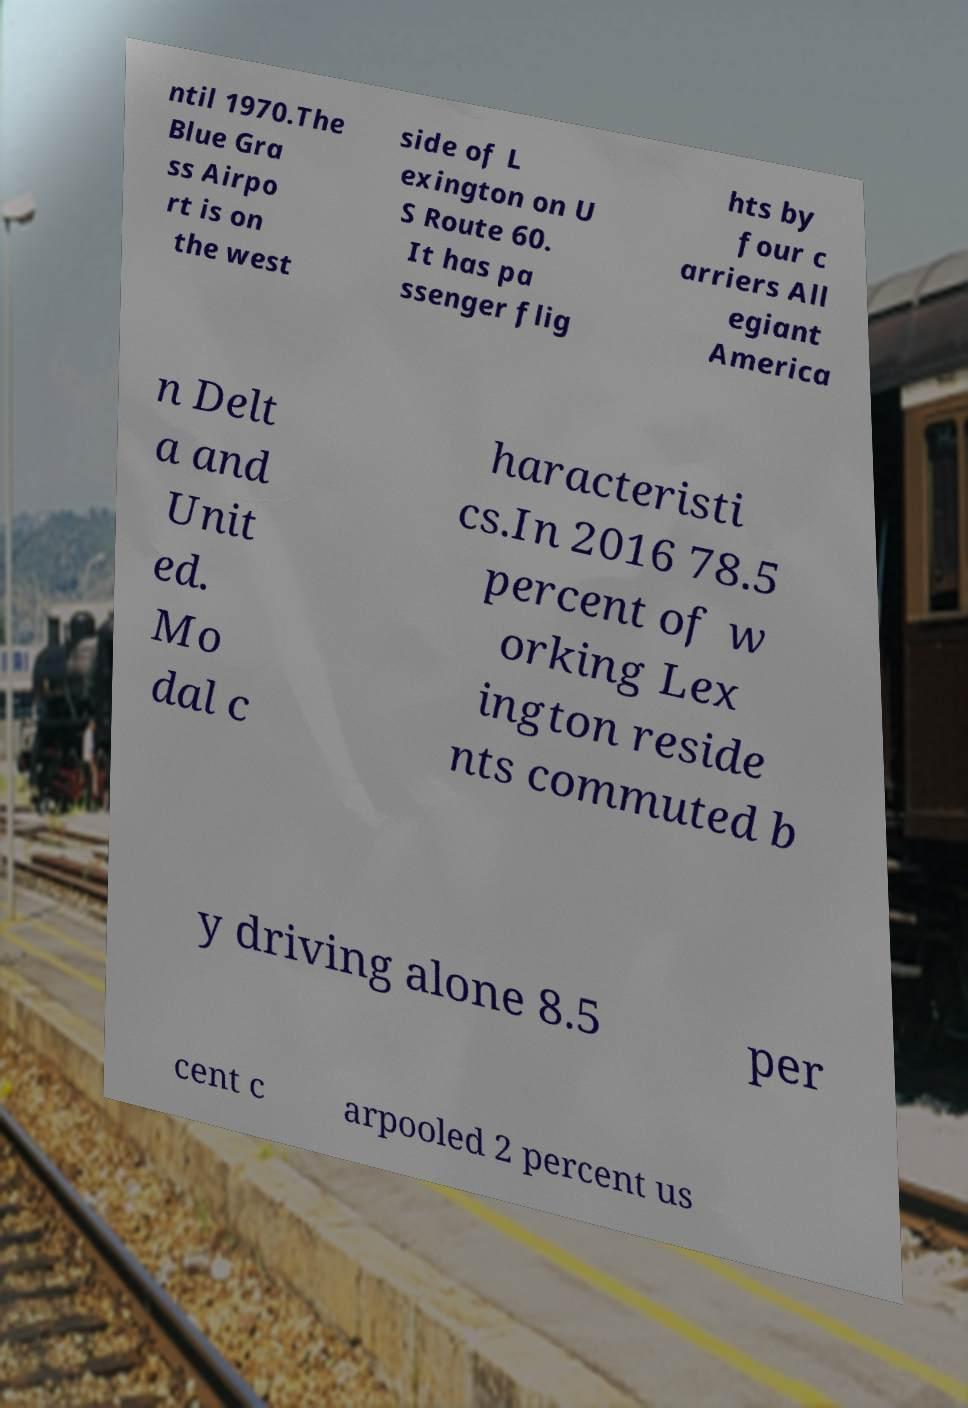There's text embedded in this image that I need extracted. Can you transcribe it verbatim? ntil 1970.The Blue Gra ss Airpo rt is on the west side of L exington on U S Route 60. It has pa ssenger flig hts by four c arriers All egiant America n Delt a and Unit ed. Mo dal c haracteristi cs.In 2016 78.5 percent of w orking Lex ington reside nts commuted b y driving alone 8.5 per cent c arpooled 2 percent us 